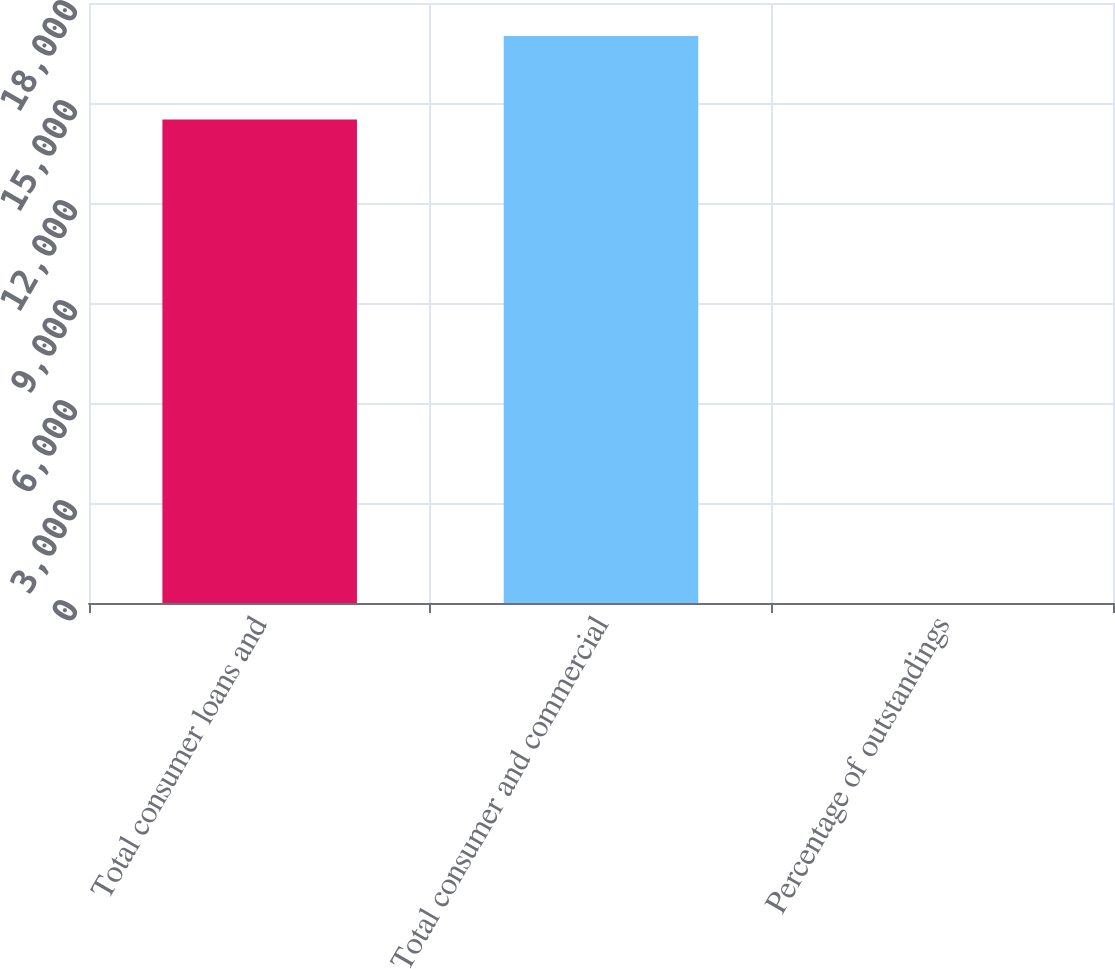<chart> <loc_0><loc_0><loc_500><loc_500><bar_chart><fcel>Total consumer loans and<fcel>Total consumer and commercial<fcel>Percentage of outstandings<nl><fcel>14506<fcel>17008<fcel>1.86<nl></chart> 